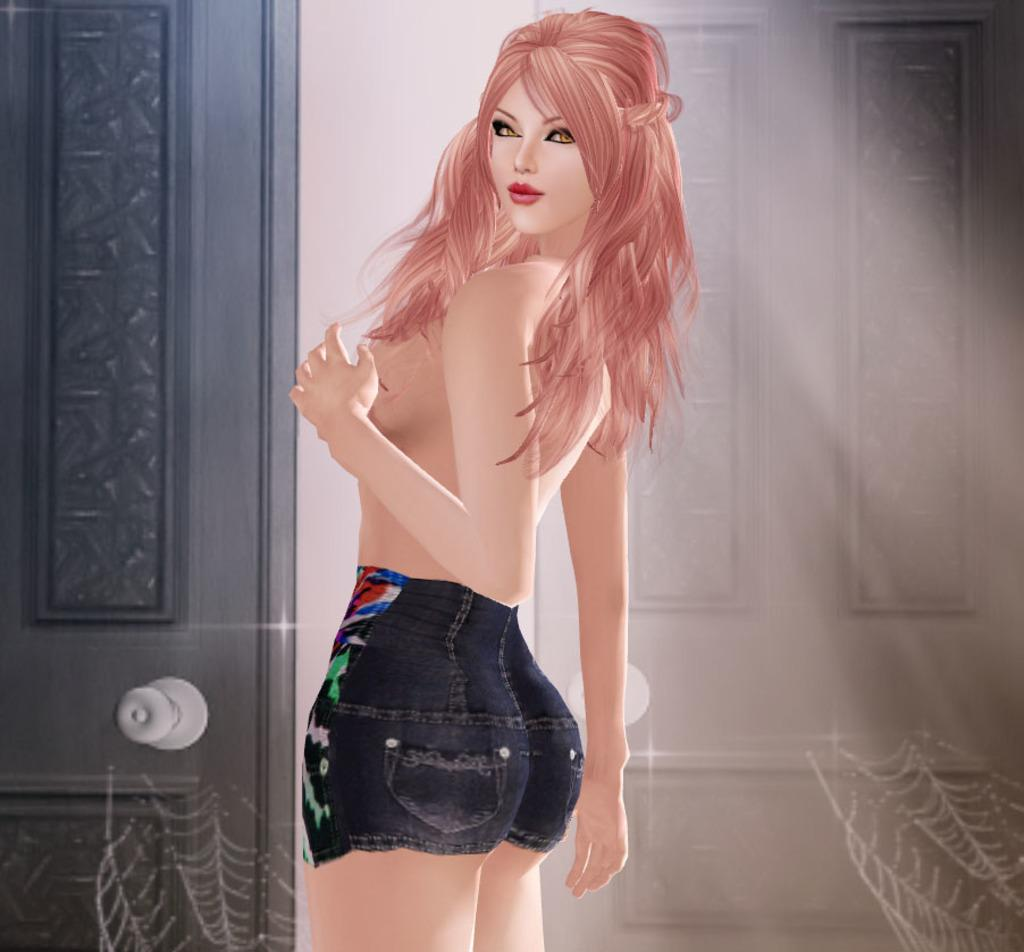What is the main subject of the image? There is a woman standing in the image. What structure can be seen in the background? There is a door visible in the image. What type of natural formation is present at the bottom of the image? Spider webs are present at the bottom of the image. What type of record can be seen on the woman's shoulder in the image? There is no record present in the image; it only features a woman standing, a door in the background, and spider webs at the bottom. 